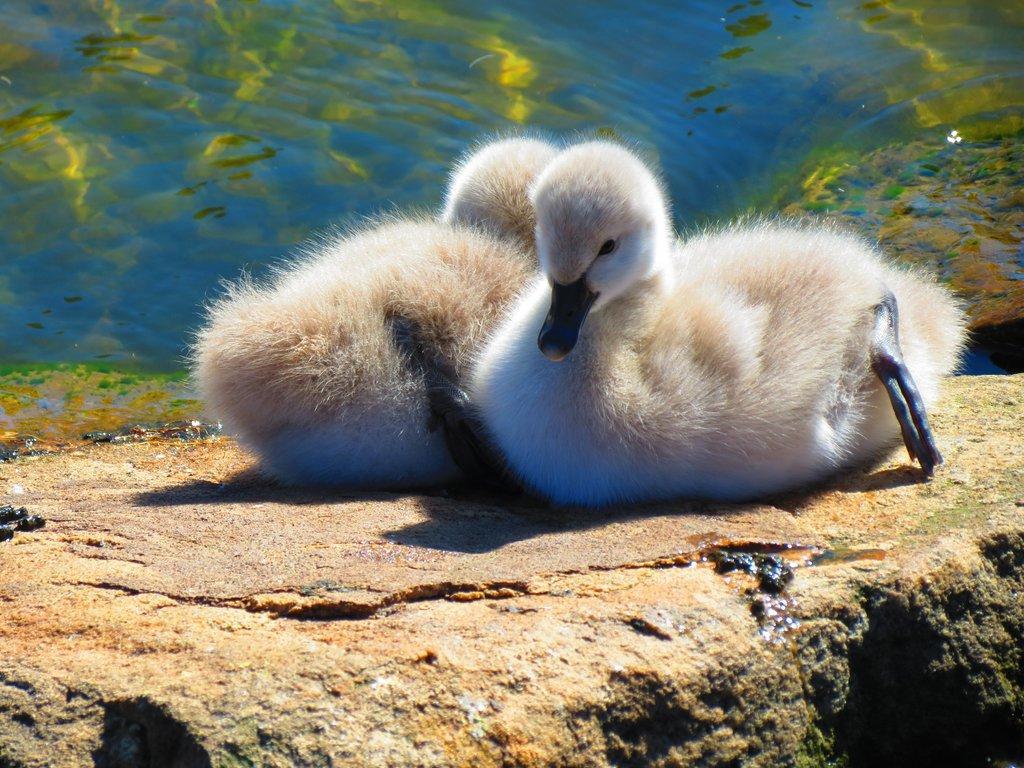Could you give a brief overview of what you see in this image? There are two white color ducks are present on the rock surface. 